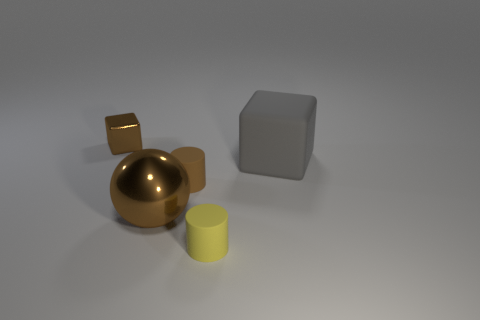There is a big gray object; are there any things behind it? Yes, behind the large gray cube, there are a couple of smaller objects: a golden sphere and a smaller cube-like object that has a reflective surface, indicating it might be metallic. The soft lighting creates gentle shadows, making it a bit more challenging to see immediately, but they are definitely there. 